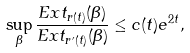Convert formula to latex. <formula><loc_0><loc_0><loc_500><loc_500>\sup _ { \beta } \frac { E x t _ { r ( t ) } ( \beta ) } { E x t _ { r ^ { \prime } ( t ) } ( \beta ) } \leq c ( t ) e ^ { 2 t } ,</formula> 